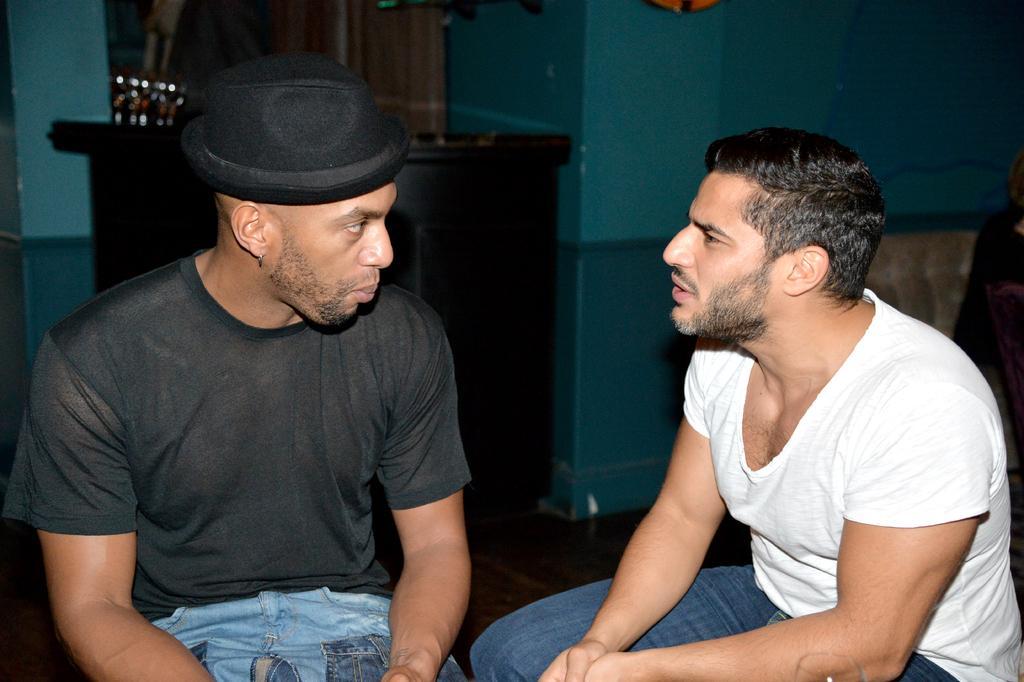How would you summarize this image in a sentence or two? In this image I can see two people with white, black and blue color dresses. In the background I can see the table and the blue color wall. 